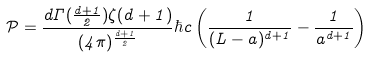<formula> <loc_0><loc_0><loc_500><loc_500>\mathcal { P } = \frac { d \Gamma ( \frac { d + 1 } { 2 } ) \zeta ( d + 1 ) } { ( 4 \pi ) ^ { \frac { d + 1 } { 2 } } } \hbar { c } \left ( \frac { 1 } { ( L - a ) ^ { d + 1 } } - \frac { 1 } { a ^ { d + 1 } } \right )</formula> 